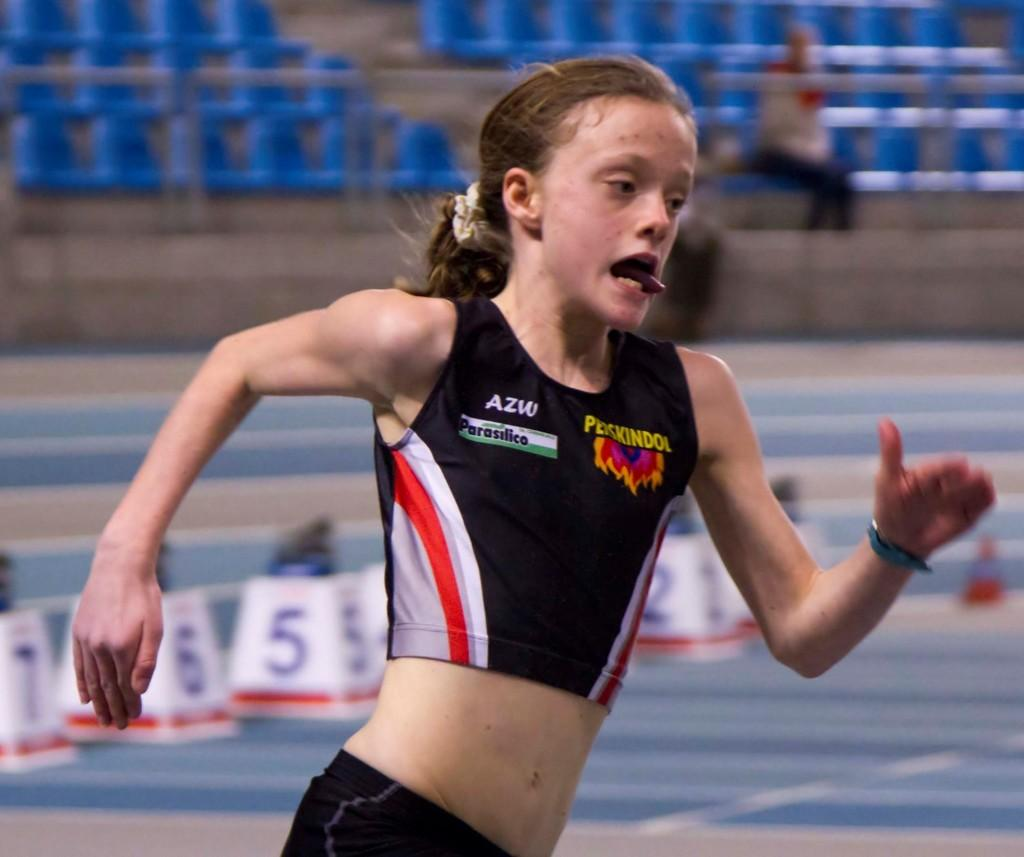<image>
Provide a brief description of the given image. AZW is the sponsor shown on this athlete's jersey. 